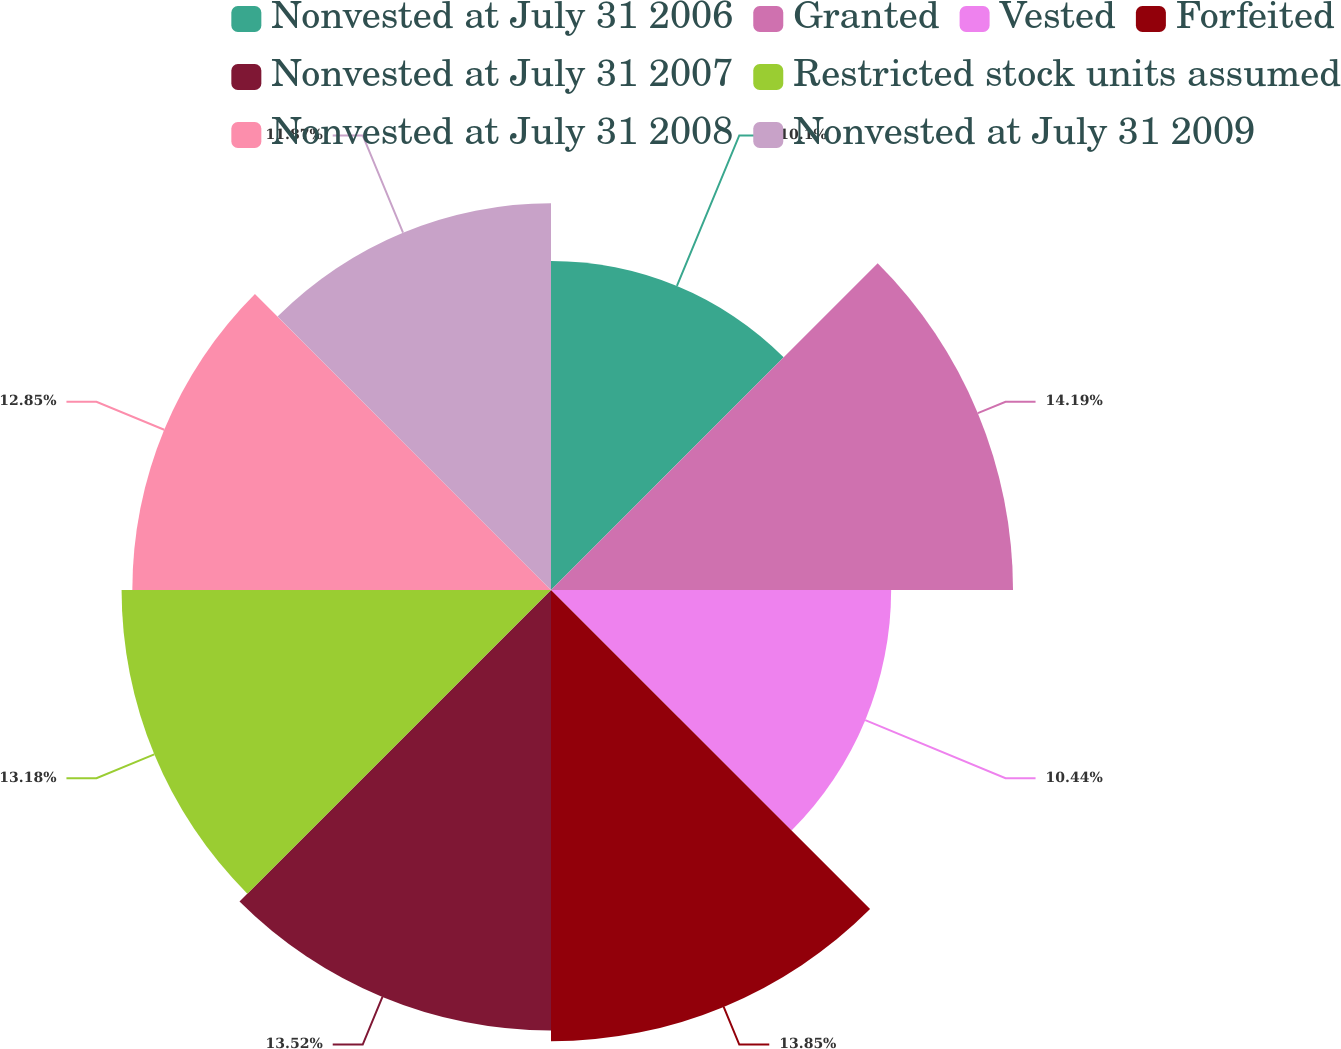Convert chart to OTSL. <chart><loc_0><loc_0><loc_500><loc_500><pie_chart><fcel>Nonvested at July 31 2006<fcel>Granted<fcel>Vested<fcel>Forfeited<fcel>Nonvested at July 31 2007<fcel>Restricted stock units assumed<fcel>Nonvested at July 31 2008<fcel>Nonvested at July 31 2009<nl><fcel>10.1%<fcel>14.18%<fcel>10.44%<fcel>13.85%<fcel>13.52%<fcel>13.18%<fcel>12.85%<fcel>11.87%<nl></chart> 